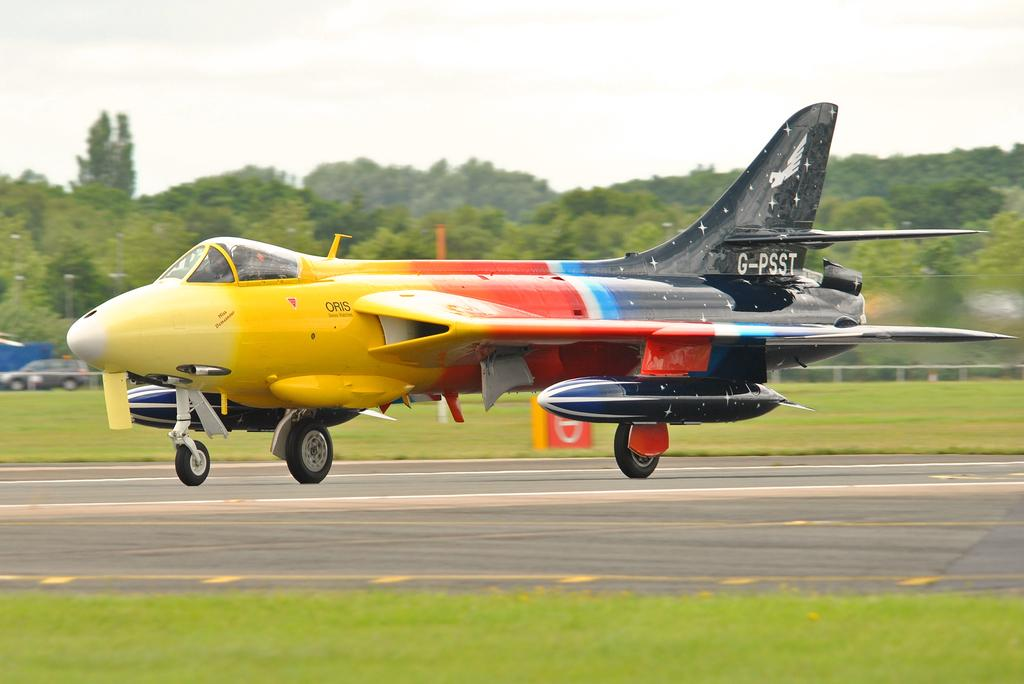<image>
Create a compact narrative representing the image presented. A multi-colored fighter jet is taking off with the tail number G-PSST. 